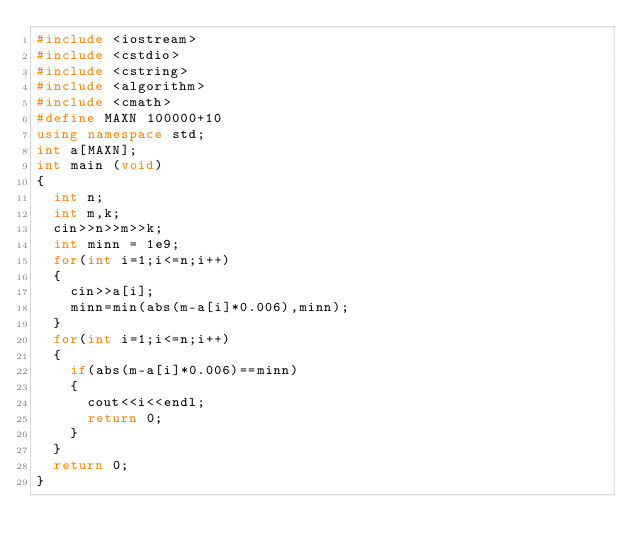<code> <loc_0><loc_0><loc_500><loc_500><_C++_>#include <iostream>
#include <cstdio>
#include <cstring>
#include <algorithm>
#include <cmath>
#define MAXN 100000+10
using namespace std;
int a[MAXN];
int main (void)
{
	int n;
	int m,k;
	cin>>n>>m>>k;
	int minn = 1e9;
	for(int i=1;i<=n;i++)
	{
		cin>>a[i];
		minn=min(abs(m-a[i]*0.006),minn);
	}
	for(int i=1;i<=n;i++)
	{
		if(abs(m-a[i]*0.006)==minn)
		{
			cout<<i<<endl;
			return 0;
		}
	}
	return 0;
}
</code> 